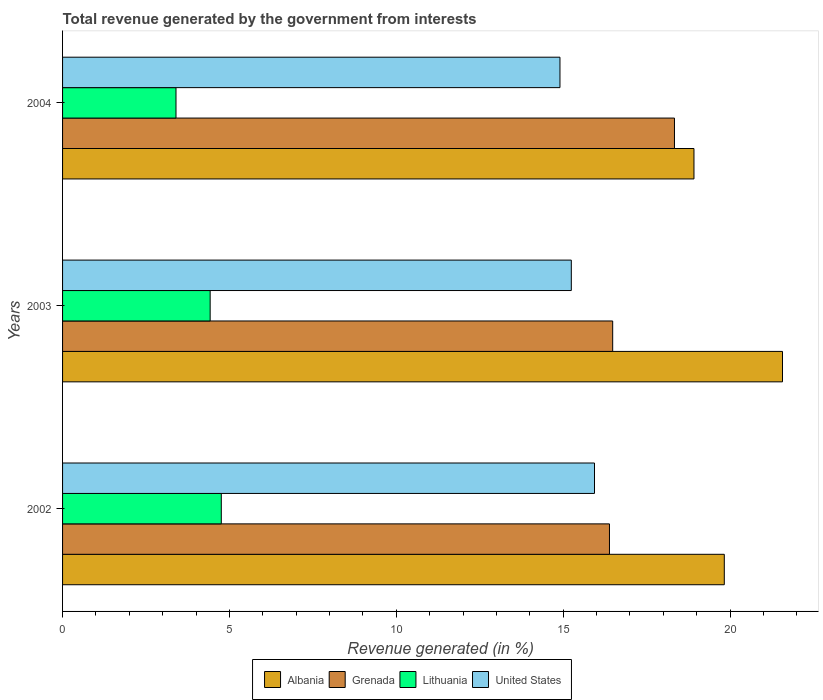How many bars are there on the 3rd tick from the top?
Offer a terse response. 4. In how many cases, is the number of bars for a given year not equal to the number of legend labels?
Provide a short and direct response. 0. What is the total revenue generated in Grenada in 2003?
Make the answer very short. 16.48. Across all years, what is the maximum total revenue generated in United States?
Your answer should be compact. 15.94. Across all years, what is the minimum total revenue generated in United States?
Keep it short and to the point. 14.9. In which year was the total revenue generated in United States maximum?
Provide a succinct answer. 2002. In which year was the total revenue generated in Albania minimum?
Give a very brief answer. 2004. What is the total total revenue generated in Lithuania in the graph?
Provide a succinct answer. 12.58. What is the difference between the total revenue generated in Lithuania in 2003 and that in 2004?
Give a very brief answer. 1.02. What is the difference between the total revenue generated in United States in 2004 and the total revenue generated in Grenada in 2003?
Ensure brevity in your answer.  -1.58. What is the average total revenue generated in Lithuania per year?
Offer a very short reply. 4.19. In the year 2003, what is the difference between the total revenue generated in Grenada and total revenue generated in Lithuania?
Your answer should be compact. 12.06. What is the ratio of the total revenue generated in Albania in 2003 to that in 2004?
Make the answer very short. 1.14. Is the total revenue generated in United States in 2002 less than that in 2004?
Provide a short and direct response. No. Is the difference between the total revenue generated in Grenada in 2002 and 2003 greater than the difference between the total revenue generated in Lithuania in 2002 and 2003?
Keep it short and to the point. No. What is the difference between the highest and the second highest total revenue generated in United States?
Your answer should be compact. 0.7. What is the difference between the highest and the lowest total revenue generated in Lithuania?
Keep it short and to the point. 1.36. What does the 4th bar from the top in 2002 represents?
Offer a terse response. Albania. What does the 1st bar from the bottom in 2002 represents?
Provide a short and direct response. Albania. How many bars are there?
Ensure brevity in your answer.  12. What is the difference between two consecutive major ticks on the X-axis?
Your answer should be compact. 5. Does the graph contain grids?
Provide a short and direct response. No. Where does the legend appear in the graph?
Keep it short and to the point. Bottom center. What is the title of the graph?
Provide a short and direct response. Total revenue generated by the government from interests. What is the label or title of the X-axis?
Provide a short and direct response. Revenue generated (in %). What is the label or title of the Y-axis?
Provide a short and direct response. Years. What is the Revenue generated (in %) in Albania in 2002?
Offer a terse response. 19.83. What is the Revenue generated (in %) of Grenada in 2002?
Give a very brief answer. 16.39. What is the Revenue generated (in %) of Lithuania in 2002?
Your answer should be very brief. 4.76. What is the Revenue generated (in %) of United States in 2002?
Provide a short and direct response. 15.94. What is the Revenue generated (in %) in Albania in 2003?
Offer a terse response. 21.57. What is the Revenue generated (in %) of Grenada in 2003?
Your response must be concise. 16.48. What is the Revenue generated (in %) of Lithuania in 2003?
Keep it short and to the point. 4.42. What is the Revenue generated (in %) in United States in 2003?
Give a very brief answer. 15.24. What is the Revenue generated (in %) in Albania in 2004?
Provide a succinct answer. 18.92. What is the Revenue generated (in %) of Grenada in 2004?
Give a very brief answer. 18.34. What is the Revenue generated (in %) in Lithuania in 2004?
Offer a terse response. 3.4. What is the Revenue generated (in %) of United States in 2004?
Keep it short and to the point. 14.9. Across all years, what is the maximum Revenue generated (in %) in Albania?
Your answer should be compact. 21.57. Across all years, what is the maximum Revenue generated (in %) of Grenada?
Ensure brevity in your answer.  18.34. Across all years, what is the maximum Revenue generated (in %) in Lithuania?
Keep it short and to the point. 4.76. Across all years, what is the maximum Revenue generated (in %) in United States?
Give a very brief answer. 15.94. Across all years, what is the minimum Revenue generated (in %) in Albania?
Keep it short and to the point. 18.92. Across all years, what is the minimum Revenue generated (in %) in Grenada?
Give a very brief answer. 16.39. Across all years, what is the minimum Revenue generated (in %) in Lithuania?
Your answer should be very brief. 3.4. Across all years, what is the minimum Revenue generated (in %) of United States?
Keep it short and to the point. 14.9. What is the total Revenue generated (in %) in Albania in the graph?
Your answer should be very brief. 60.32. What is the total Revenue generated (in %) in Grenada in the graph?
Offer a terse response. 51.21. What is the total Revenue generated (in %) in Lithuania in the graph?
Offer a very short reply. 12.58. What is the total Revenue generated (in %) of United States in the graph?
Ensure brevity in your answer.  46.09. What is the difference between the Revenue generated (in %) of Albania in 2002 and that in 2003?
Give a very brief answer. -1.74. What is the difference between the Revenue generated (in %) in Grenada in 2002 and that in 2003?
Ensure brevity in your answer.  -0.1. What is the difference between the Revenue generated (in %) of Lithuania in 2002 and that in 2003?
Provide a short and direct response. 0.33. What is the difference between the Revenue generated (in %) of United States in 2002 and that in 2003?
Your answer should be very brief. 0.69. What is the difference between the Revenue generated (in %) of Albania in 2002 and that in 2004?
Ensure brevity in your answer.  0.91. What is the difference between the Revenue generated (in %) in Grenada in 2002 and that in 2004?
Ensure brevity in your answer.  -1.95. What is the difference between the Revenue generated (in %) of Lithuania in 2002 and that in 2004?
Ensure brevity in your answer.  1.36. What is the difference between the Revenue generated (in %) of United States in 2002 and that in 2004?
Your response must be concise. 1.03. What is the difference between the Revenue generated (in %) in Albania in 2003 and that in 2004?
Ensure brevity in your answer.  2.65. What is the difference between the Revenue generated (in %) in Grenada in 2003 and that in 2004?
Provide a succinct answer. -1.85. What is the difference between the Revenue generated (in %) in Lithuania in 2003 and that in 2004?
Provide a short and direct response. 1.02. What is the difference between the Revenue generated (in %) of United States in 2003 and that in 2004?
Your answer should be very brief. 0.34. What is the difference between the Revenue generated (in %) in Albania in 2002 and the Revenue generated (in %) in Grenada in 2003?
Make the answer very short. 3.34. What is the difference between the Revenue generated (in %) of Albania in 2002 and the Revenue generated (in %) of Lithuania in 2003?
Offer a very short reply. 15.41. What is the difference between the Revenue generated (in %) of Albania in 2002 and the Revenue generated (in %) of United States in 2003?
Ensure brevity in your answer.  4.58. What is the difference between the Revenue generated (in %) in Grenada in 2002 and the Revenue generated (in %) in Lithuania in 2003?
Ensure brevity in your answer.  11.96. What is the difference between the Revenue generated (in %) in Grenada in 2002 and the Revenue generated (in %) in United States in 2003?
Your response must be concise. 1.14. What is the difference between the Revenue generated (in %) in Lithuania in 2002 and the Revenue generated (in %) in United States in 2003?
Offer a terse response. -10.49. What is the difference between the Revenue generated (in %) in Albania in 2002 and the Revenue generated (in %) in Grenada in 2004?
Give a very brief answer. 1.49. What is the difference between the Revenue generated (in %) in Albania in 2002 and the Revenue generated (in %) in Lithuania in 2004?
Keep it short and to the point. 16.43. What is the difference between the Revenue generated (in %) of Albania in 2002 and the Revenue generated (in %) of United States in 2004?
Offer a very short reply. 4.92. What is the difference between the Revenue generated (in %) of Grenada in 2002 and the Revenue generated (in %) of Lithuania in 2004?
Offer a terse response. 12.99. What is the difference between the Revenue generated (in %) of Grenada in 2002 and the Revenue generated (in %) of United States in 2004?
Give a very brief answer. 1.48. What is the difference between the Revenue generated (in %) of Lithuania in 2002 and the Revenue generated (in %) of United States in 2004?
Make the answer very short. -10.15. What is the difference between the Revenue generated (in %) in Albania in 2003 and the Revenue generated (in %) in Grenada in 2004?
Offer a very short reply. 3.24. What is the difference between the Revenue generated (in %) of Albania in 2003 and the Revenue generated (in %) of Lithuania in 2004?
Your answer should be very brief. 18.17. What is the difference between the Revenue generated (in %) of Albania in 2003 and the Revenue generated (in %) of United States in 2004?
Ensure brevity in your answer.  6.67. What is the difference between the Revenue generated (in %) of Grenada in 2003 and the Revenue generated (in %) of Lithuania in 2004?
Your answer should be very brief. 13.09. What is the difference between the Revenue generated (in %) in Grenada in 2003 and the Revenue generated (in %) in United States in 2004?
Your response must be concise. 1.58. What is the difference between the Revenue generated (in %) in Lithuania in 2003 and the Revenue generated (in %) in United States in 2004?
Your answer should be compact. -10.48. What is the average Revenue generated (in %) of Albania per year?
Ensure brevity in your answer.  20.11. What is the average Revenue generated (in %) of Grenada per year?
Offer a terse response. 17.07. What is the average Revenue generated (in %) in Lithuania per year?
Provide a succinct answer. 4.19. What is the average Revenue generated (in %) of United States per year?
Your response must be concise. 15.36. In the year 2002, what is the difference between the Revenue generated (in %) in Albania and Revenue generated (in %) in Grenada?
Your response must be concise. 3.44. In the year 2002, what is the difference between the Revenue generated (in %) of Albania and Revenue generated (in %) of Lithuania?
Make the answer very short. 15.07. In the year 2002, what is the difference between the Revenue generated (in %) in Albania and Revenue generated (in %) in United States?
Offer a very short reply. 3.89. In the year 2002, what is the difference between the Revenue generated (in %) of Grenada and Revenue generated (in %) of Lithuania?
Offer a very short reply. 11.63. In the year 2002, what is the difference between the Revenue generated (in %) in Grenada and Revenue generated (in %) in United States?
Your answer should be compact. 0.45. In the year 2002, what is the difference between the Revenue generated (in %) of Lithuania and Revenue generated (in %) of United States?
Provide a succinct answer. -11.18. In the year 2003, what is the difference between the Revenue generated (in %) in Albania and Revenue generated (in %) in Grenada?
Provide a short and direct response. 5.09. In the year 2003, what is the difference between the Revenue generated (in %) of Albania and Revenue generated (in %) of Lithuania?
Ensure brevity in your answer.  17.15. In the year 2003, what is the difference between the Revenue generated (in %) in Albania and Revenue generated (in %) in United States?
Provide a succinct answer. 6.33. In the year 2003, what is the difference between the Revenue generated (in %) in Grenada and Revenue generated (in %) in Lithuania?
Your answer should be very brief. 12.06. In the year 2003, what is the difference between the Revenue generated (in %) of Grenada and Revenue generated (in %) of United States?
Your response must be concise. 1.24. In the year 2003, what is the difference between the Revenue generated (in %) in Lithuania and Revenue generated (in %) in United States?
Keep it short and to the point. -10.82. In the year 2004, what is the difference between the Revenue generated (in %) of Albania and Revenue generated (in %) of Grenada?
Give a very brief answer. 0.58. In the year 2004, what is the difference between the Revenue generated (in %) in Albania and Revenue generated (in %) in Lithuania?
Provide a succinct answer. 15.52. In the year 2004, what is the difference between the Revenue generated (in %) of Albania and Revenue generated (in %) of United States?
Ensure brevity in your answer.  4.02. In the year 2004, what is the difference between the Revenue generated (in %) of Grenada and Revenue generated (in %) of Lithuania?
Make the answer very short. 14.94. In the year 2004, what is the difference between the Revenue generated (in %) of Grenada and Revenue generated (in %) of United States?
Give a very brief answer. 3.43. In the year 2004, what is the difference between the Revenue generated (in %) of Lithuania and Revenue generated (in %) of United States?
Give a very brief answer. -11.51. What is the ratio of the Revenue generated (in %) in Albania in 2002 to that in 2003?
Your response must be concise. 0.92. What is the ratio of the Revenue generated (in %) of Grenada in 2002 to that in 2003?
Make the answer very short. 0.99. What is the ratio of the Revenue generated (in %) in Lithuania in 2002 to that in 2003?
Offer a terse response. 1.08. What is the ratio of the Revenue generated (in %) in United States in 2002 to that in 2003?
Offer a very short reply. 1.05. What is the ratio of the Revenue generated (in %) in Albania in 2002 to that in 2004?
Provide a succinct answer. 1.05. What is the ratio of the Revenue generated (in %) in Grenada in 2002 to that in 2004?
Make the answer very short. 0.89. What is the ratio of the Revenue generated (in %) of Lithuania in 2002 to that in 2004?
Offer a terse response. 1.4. What is the ratio of the Revenue generated (in %) in United States in 2002 to that in 2004?
Make the answer very short. 1.07. What is the ratio of the Revenue generated (in %) in Albania in 2003 to that in 2004?
Provide a succinct answer. 1.14. What is the ratio of the Revenue generated (in %) of Grenada in 2003 to that in 2004?
Provide a succinct answer. 0.9. What is the ratio of the Revenue generated (in %) of Lithuania in 2003 to that in 2004?
Your response must be concise. 1.3. What is the ratio of the Revenue generated (in %) of United States in 2003 to that in 2004?
Keep it short and to the point. 1.02. What is the difference between the highest and the second highest Revenue generated (in %) in Albania?
Provide a short and direct response. 1.74. What is the difference between the highest and the second highest Revenue generated (in %) of Grenada?
Your response must be concise. 1.85. What is the difference between the highest and the second highest Revenue generated (in %) of Lithuania?
Make the answer very short. 0.33. What is the difference between the highest and the second highest Revenue generated (in %) in United States?
Keep it short and to the point. 0.69. What is the difference between the highest and the lowest Revenue generated (in %) in Albania?
Provide a succinct answer. 2.65. What is the difference between the highest and the lowest Revenue generated (in %) in Grenada?
Provide a short and direct response. 1.95. What is the difference between the highest and the lowest Revenue generated (in %) in Lithuania?
Your response must be concise. 1.36. What is the difference between the highest and the lowest Revenue generated (in %) of United States?
Your response must be concise. 1.03. 